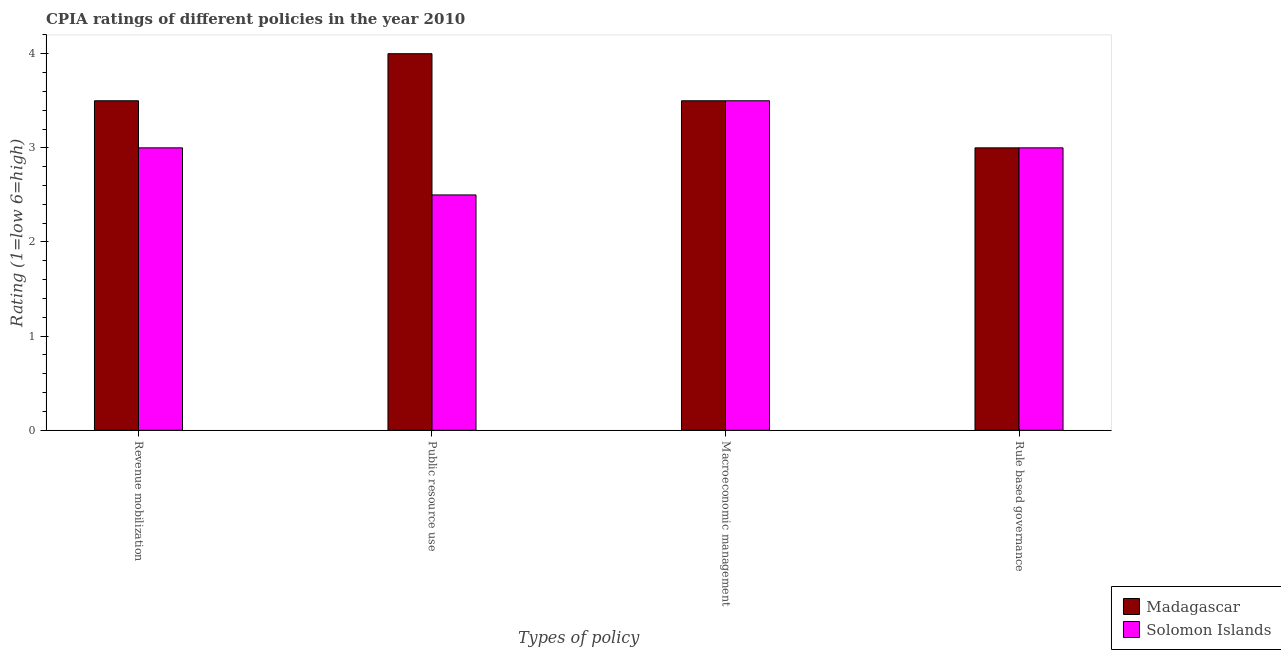How many groups of bars are there?
Your answer should be very brief. 4. How many bars are there on the 2nd tick from the left?
Provide a succinct answer. 2. How many bars are there on the 1st tick from the right?
Keep it short and to the point. 2. What is the label of the 4th group of bars from the left?
Give a very brief answer. Rule based governance. In which country was the cpia rating of revenue mobilization maximum?
Your answer should be very brief. Madagascar. In which country was the cpia rating of rule based governance minimum?
Provide a short and direct response. Madagascar. What is the total cpia rating of macroeconomic management in the graph?
Give a very brief answer. 7. What is the difference between the cpia rating of macroeconomic management in Solomon Islands and the cpia rating of public resource use in Madagascar?
Offer a terse response. -0.5. What is the average cpia rating of rule based governance per country?
Provide a succinct answer. 3. What is the difference between the cpia rating of rule based governance and cpia rating of public resource use in Madagascar?
Keep it short and to the point. -1. Is the cpia rating of public resource use in Solomon Islands less than that in Madagascar?
Keep it short and to the point. Yes. Is the difference between the cpia rating of rule based governance in Solomon Islands and Madagascar greater than the difference between the cpia rating of macroeconomic management in Solomon Islands and Madagascar?
Keep it short and to the point. No. What is the difference between the highest and the second highest cpia rating of macroeconomic management?
Give a very brief answer. 0. Is the sum of the cpia rating of rule based governance in Solomon Islands and Madagascar greater than the maximum cpia rating of macroeconomic management across all countries?
Offer a terse response. Yes. Is it the case that in every country, the sum of the cpia rating of public resource use and cpia rating of rule based governance is greater than the sum of cpia rating of revenue mobilization and cpia rating of macroeconomic management?
Your answer should be compact. No. What does the 1st bar from the left in Macroeconomic management represents?
Offer a terse response. Madagascar. What does the 2nd bar from the right in Revenue mobilization represents?
Your answer should be compact. Madagascar. How many bars are there?
Give a very brief answer. 8. What is the difference between two consecutive major ticks on the Y-axis?
Your response must be concise. 1. Does the graph contain any zero values?
Your response must be concise. No. Where does the legend appear in the graph?
Keep it short and to the point. Bottom right. How many legend labels are there?
Ensure brevity in your answer.  2. How are the legend labels stacked?
Offer a very short reply. Vertical. What is the title of the graph?
Ensure brevity in your answer.  CPIA ratings of different policies in the year 2010. Does "West Bank and Gaza" appear as one of the legend labels in the graph?
Your answer should be very brief. No. What is the label or title of the X-axis?
Offer a very short reply. Types of policy. What is the label or title of the Y-axis?
Make the answer very short. Rating (1=low 6=high). What is the Rating (1=low 6=high) of Solomon Islands in Public resource use?
Provide a succinct answer. 2.5. What is the Rating (1=low 6=high) of Madagascar in Rule based governance?
Your response must be concise. 3. What is the Rating (1=low 6=high) of Solomon Islands in Rule based governance?
Ensure brevity in your answer.  3. Across all Types of policy, what is the minimum Rating (1=low 6=high) of Madagascar?
Provide a short and direct response. 3. What is the total Rating (1=low 6=high) in Solomon Islands in the graph?
Offer a very short reply. 12. What is the difference between the Rating (1=low 6=high) in Madagascar in Revenue mobilization and that in Public resource use?
Your response must be concise. -0.5. What is the difference between the Rating (1=low 6=high) of Madagascar in Revenue mobilization and that in Macroeconomic management?
Ensure brevity in your answer.  0. What is the difference between the Rating (1=low 6=high) in Madagascar in Revenue mobilization and that in Rule based governance?
Keep it short and to the point. 0.5. What is the difference between the Rating (1=low 6=high) in Madagascar in Public resource use and that in Rule based governance?
Provide a short and direct response. 1. What is the difference between the Rating (1=low 6=high) in Madagascar in Macroeconomic management and that in Rule based governance?
Keep it short and to the point. 0.5. What is the difference between the Rating (1=low 6=high) in Madagascar in Public resource use and the Rating (1=low 6=high) in Solomon Islands in Macroeconomic management?
Your response must be concise. 0.5. What is the difference between the Rating (1=low 6=high) of Madagascar in Public resource use and the Rating (1=low 6=high) of Solomon Islands in Rule based governance?
Give a very brief answer. 1. What is the average Rating (1=low 6=high) in Madagascar per Types of policy?
Offer a very short reply. 3.5. What is the average Rating (1=low 6=high) of Solomon Islands per Types of policy?
Provide a short and direct response. 3. What is the difference between the Rating (1=low 6=high) of Madagascar and Rating (1=low 6=high) of Solomon Islands in Rule based governance?
Ensure brevity in your answer.  0. What is the ratio of the Rating (1=low 6=high) in Solomon Islands in Revenue mobilization to that in Public resource use?
Ensure brevity in your answer.  1.2. What is the ratio of the Rating (1=low 6=high) in Madagascar in Revenue mobilization to that in Macroeconomic management?
Your answer should be compact. 1. What is the ratio of the Rating (1=low 6=high) in Solomon Islands in Public resource use to that in Macroeconomic management?
Give a very brief answer. 0.71. What is the ratio of the Rating (1=low 6=high) in Solomon Islands in Public resource use to that in Rule based governance?
Offer a very short reply. 0.83. What is the ratio of the Rating (1=low 6=high) in Madagascar in Macroeconomic management to that in Rule based governance?
Keep it short and to the point. 1.17. What is the ratio of the Rating (1=low 6=high) of Solomon Islands in Macroeconomic management to that in Rule based governance?
Make the answer very short. 1.17. What is the difference between the highest and the second highest Rating (1=low 6=high) of Madagascar?
Provide a short and direct response. 0.5. What is the difference between the highest and the lowest Rating (1=low 6=high) of Madagascar?
Your answer should be very brief. 1. What is the difference between the highest and the lowest Rating (1=low 6=high) of Solomon Islands?
Your answer should be very brief. 1. 